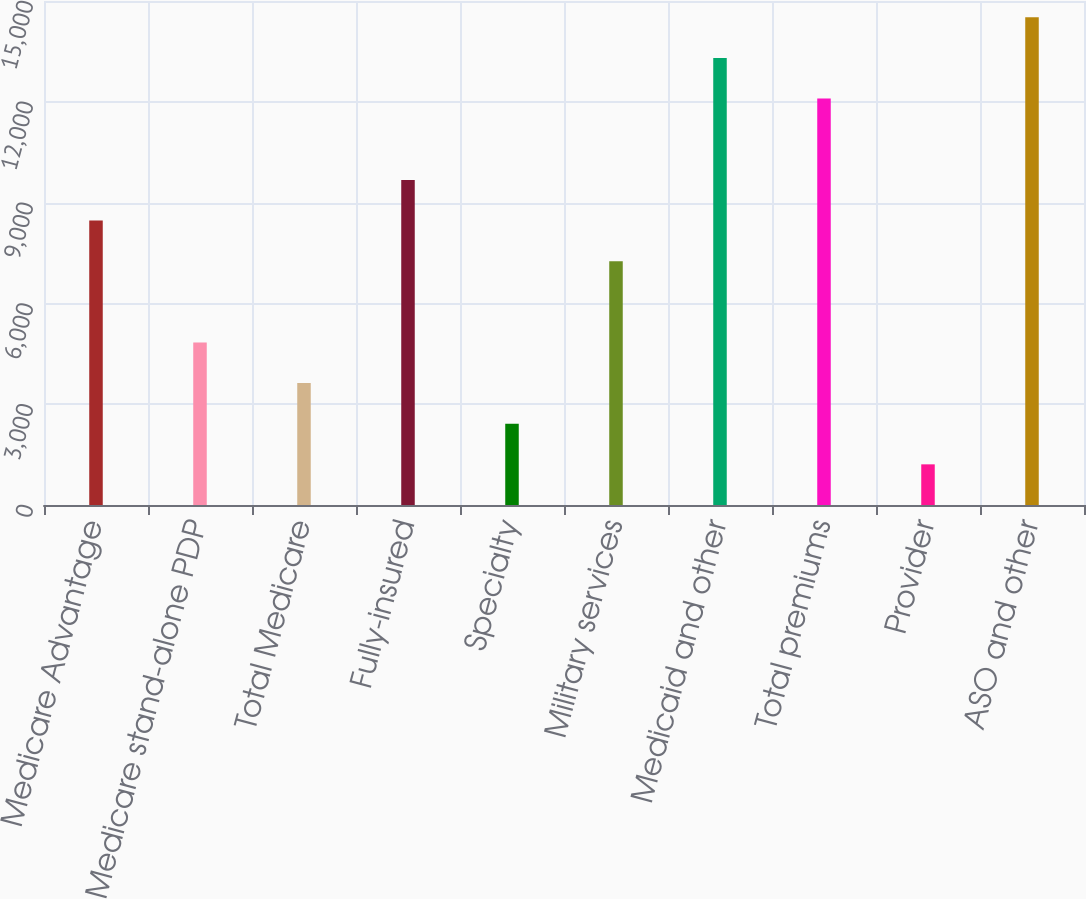<chart> <loc_0><loc_0><loc_500><loc_500><bar_chart><fcel>Medicare Advantage<fcel>Medicare stand-alone PDP<fcel>Total Medicare<fcel>Fully-insured<fcel>Specialty<fcel>Military services<fcel>Medicaid and other<fcel>Total premiums<fcel>Provider<fcel>ASO and other<nl><fcel>8466.64<fcel>4838.32<fcel>3628.88<fcel>9676.08<fcel>2419.44<fcel>7257.2<fcel>13304.4<fcel>12095<fcel>1210<fcel>14513.8<nl></chart> 